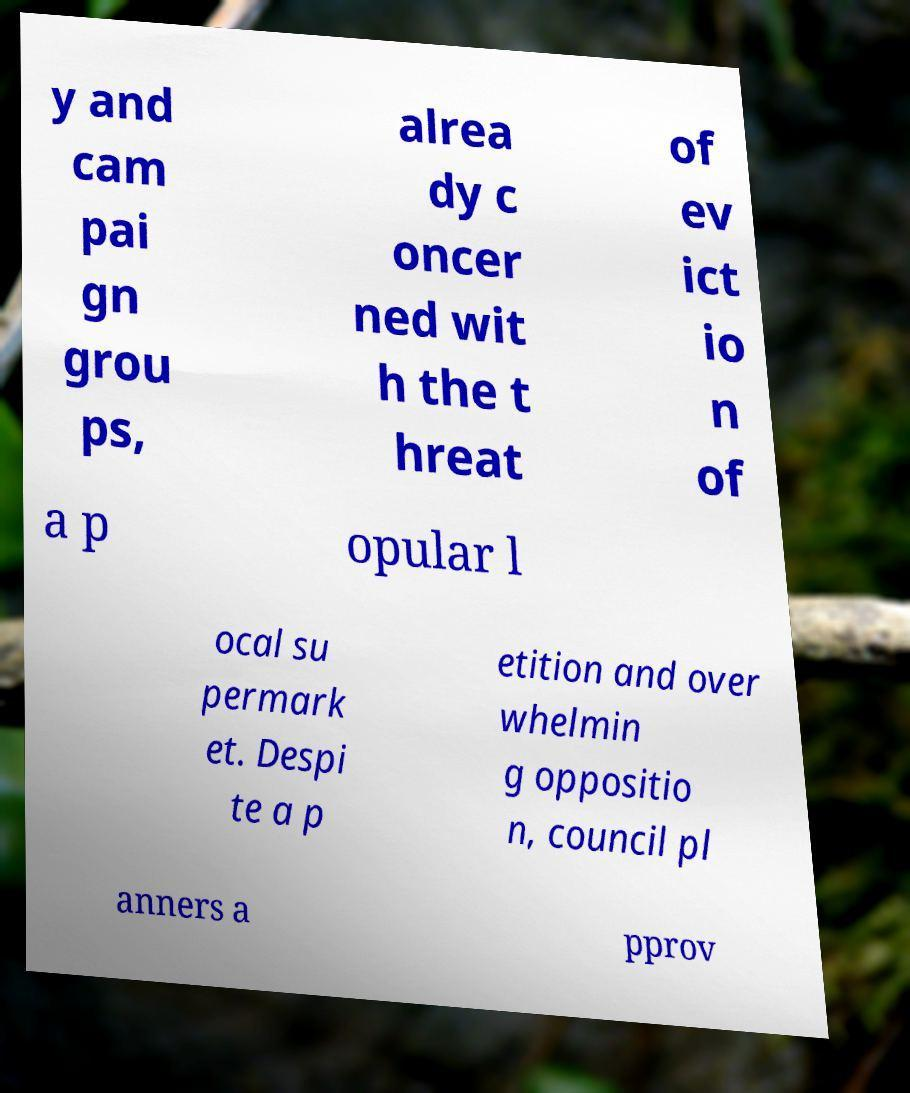There's text embedded in this image that I need extracted. Can you transcribe it verbatim? y and cam pai gn grou ps, alrea dy c oncer ned wit h the t hreat of ev ict io n of a p opular l ocal su permark et. Despi te a p etition and over whelmin g oppositio n, council pl anners a pprov 